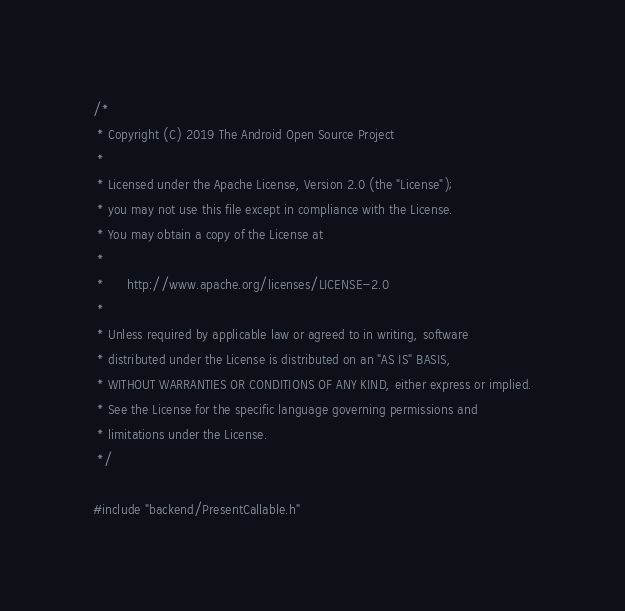Convert code to text. <code><loc_0><loc_0><loc_500><loc_500><_ObjectiveC_>/*
 * Copyright (C) 2019 The Android Open Source Project
 *
 * Licensed under the Apache License, Version 2.0 (the "License");
 * you may not use this file except in compliance with the License.
 * You may obtain a copy of the License at
 *
 *      http://www.apache.org/licenses/LICENSE-2.0
 *
 * Unless required by applicable law or agreed to in writing, software
 * distributed under the License is distributed on an "AS IS" BASIS,
 * WITHOUT WARRANTIES OR CONDITIONS OF ANY KIND, either express or implied.
 * See the License for the specific language governing permissions and
 * limitations under the License.
 */

#include "backend/PresentCallable.h"</code> 